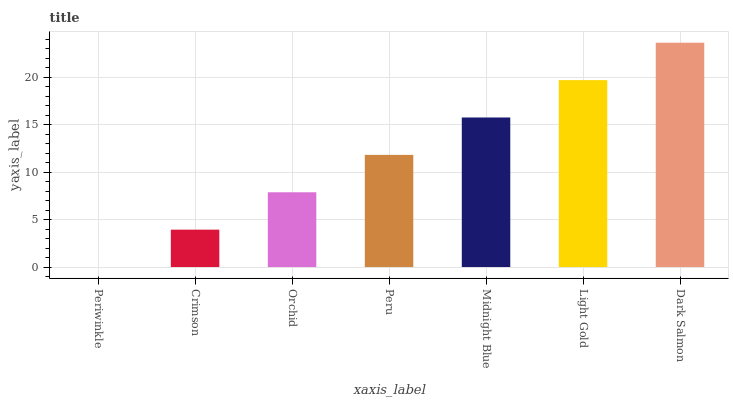Is Periwinkle the minimum?
Answer yes or no. Yes. Is Dark Salmon the maximum?
Answer yes or no. Yes. Is Crimson the minimum?
Answer yes or no. No. Is Crimson the maximum?
Answer yes or no. No. Is Crimson greater than Periwinkle?
Answer yes or no. Yes. Is Periwinkle less than Crimson?
Answer yes or no. Yes. Is Periwinkle greater than Crimson?
Answer yes or no. No. Is Crimson less than Periwinkle?
Answer yes or no. No. Is Peru the high median?
Answer yes or no. Yes. Is Peru the low median?
Answer yes or no. Yes. Is Light Gold the high median?
Answer yes or no. No. Is Orchid the low median?
Answer yes or no. No. 